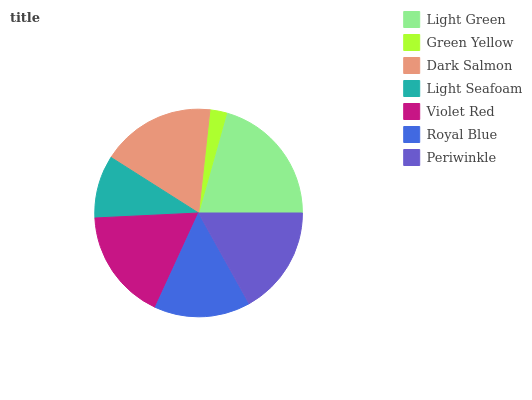Is Green Yellow the minimum?
Answer yes or no. Yes. Is Light Green the maximum?
Answer yes or no. Yes. Is Dark Salmon the minimum?
Answer yes or no. No. Is Dark Salmon the maximum?
Answer yes or no. No. Is Dark Salmon greater than Green Yellow?
Answer yes or no. Yes. Is Green Yellow less than Dark Salmon?
Answer yes or no. Yes. Is Green Yellow greater than Dark Salmon?
Answer yes or no. No. Is Dark Salmon less than Green Yellow?
Answer yes or no. No. Is Periwinkle the high median?
Answer yes or no. Yes. Is Periwinkle the low median?
Answer yes or no. Yes. Is Dark Salmon the high median?
Answer yes or no. No. Is Royal Blue the low median?
Answer yes or no. No. 